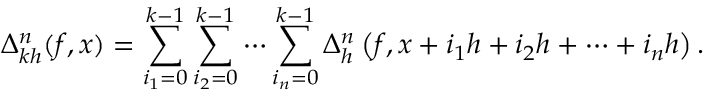<formula> <loc_0><loc_0><loc_500><loc_500>\Delta _ { k h } ^ { n } ( f , x ) = \sum _ { i _ { 1 } = 0 } ^ { k - 1 } \sum _ { i _ { 2 } = 0 } ^ { k - 1 } \cdots \sum _ { i _ { n } = 0 } ^ { k - 1 } \Delta _ { h } ^ { n } \left ( f , x + i _ { 1 } h + i _ { 2 } h + \cdots + i _ { n } h \right ) .</formula> 